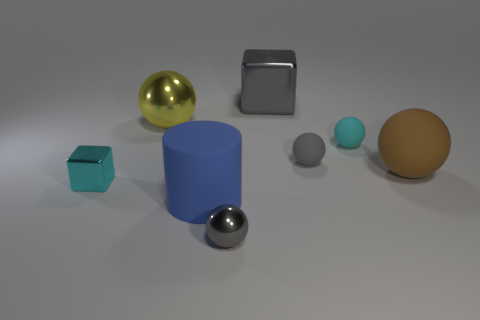Is the cyan rubber thing the same size as the gray matte object?
Your answer should be compact. Yes. What is the big cylinder made of?
Keep it short and to the point. Rubber. There is a ball that is made of the same material as the yellow object; what color is it?
Provide a short and direct response. Gray. Do the large blue thing and the large ball that is to the right of the cylinder have the same material?
Your response must be concise. Yes. What number of big yellow objects have the same material as the brown sphere?
Provide a short and direct response. 0. There is a tiny metal thing behind the cylinder; what shape is it?
Give a very brief answer. Cube. Is the material of the tiny gray object that is behind the brown object the same as the tiny object on the left side of the tiny gray shiny sphere?
Your answer should be compact. No. Is there another gray shiny object that has the same shape as the large gray thing?
Give a very brief answer. No. How many objects are things right of the yellow shiny object or big cyan cylinders?
Provide a short and direct response. 6. Is the number of tiny balls that are in front of the large blue cylinder greater than the number of gray shiny blocks in front of the large cube?
Ensure brevity in your answer.  Yes. 